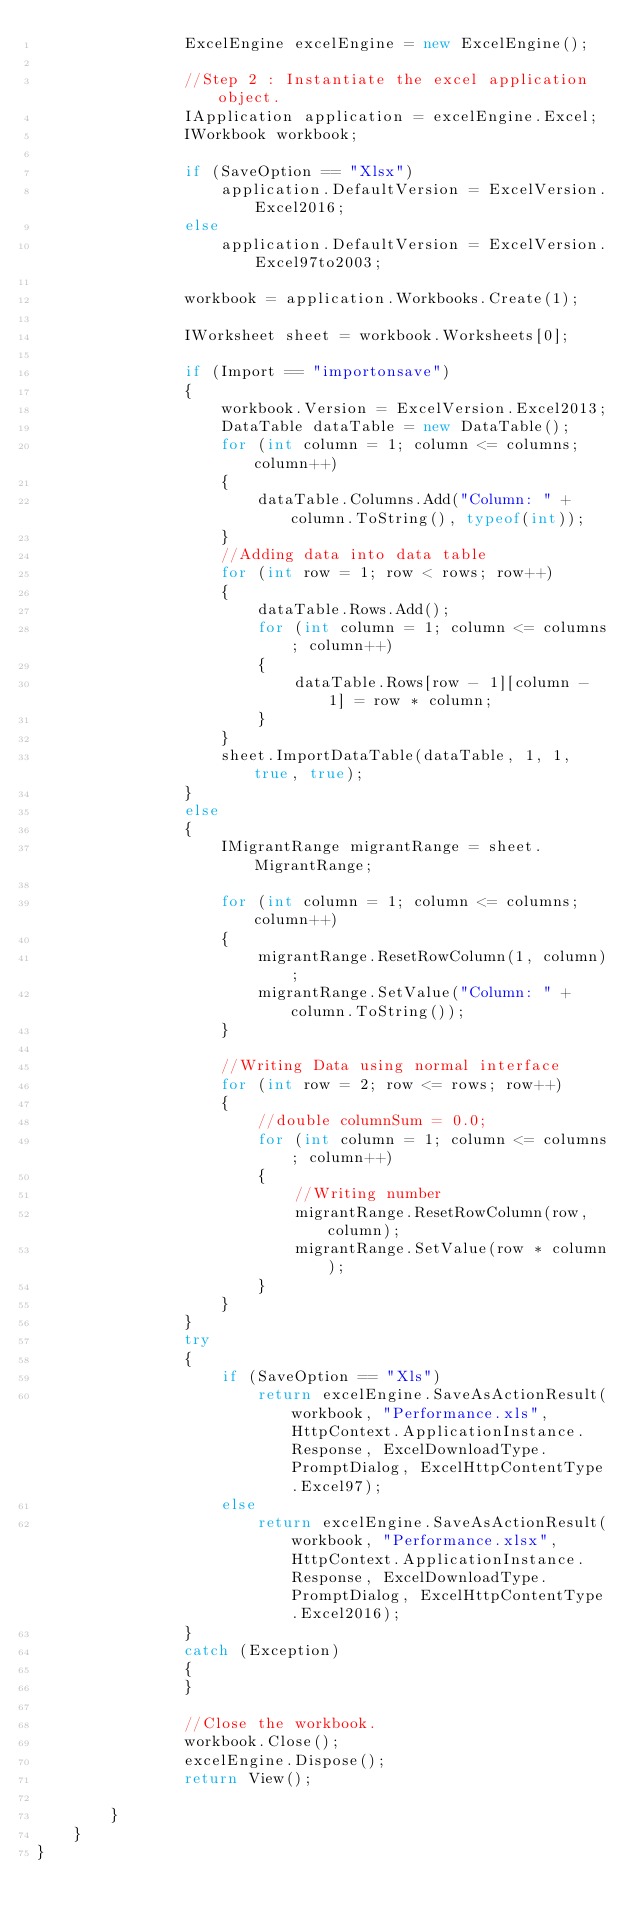Convert code to text. <code><loc_0><loc_0><loc_500><loc_500><_C#_>                ExcelEngine excelEngine = new ExcelEngine();

                //Step 2 : Instantiate the excel application object.
                IApplication application = excelEngine.Excel;
                IWorkbook workbook;

                if (SaveOption == "Xlsx")
                    application.DefaultVersion = ExcelVersion.Excel2016;
                else
                    application.DefaultVersion = ExcelVersion.Excel97to2003;
              
                workbook = application.Workbooks.Create(1);

                IWorksheet sheet = workbook.Worksheets[0];

                if (Import == "importonsave")
                {
                    workbook.Version = ExcelVersion.Excel2013;
                    DataTable dataTable = new DataTable();
                    for (int column = 1; column <= columns; column++)
                    {
                        dataTable.Columns.Add("Column: " + column.ToString(), typeof(int));
                    }
                    //Adding data into data table
                    for (int row = 1; row < rows; row++)
                    {
                        dataTable.Rows.Add();
                        for (int column = 1; column <= columns; column++)
                        {
                            dataTable.Rows[row - 1][column - 1] = row * column;
                        }
                    }
                    sheet.ImportDataTable(dataTable, 1, 1, true, true);
                }
                else
                {
                    IMigrantRange migrantRange = sheet.MigrantRange;

                    for (int column = 1; column <= columns; column++)
                    {
                        migrantRange.ResetRowColumn(1, column);
                        migrantRange.SetValue("Column: " + column.ToString());
                    }

                    //Writing Data using normal interface
                    for (int row = 2; row <= rows; row++)
                    {
                        //double columnSum = 0.0; 
                        for (int column = 1; column <= columns; column++)
                        {
                            //Writing number
                            migrantRange.ResetRowColumn(row, column);
                            migrantRange.SetValue(row * column);
                        }
                    }
                }
                try
                {
                    if (SaveOption == "Xls")
                        return excelEngine.SaveAsActionResult(workbook, "Performance.xls", HttpContext.ApplicationInstance.Response, ExcelDownloadType.PromptDialog, ExcelHttpContentType.Excel97);
                    else
                        return excelEngine.SaveAsActionResult(workbook, "Performance.xlsx", HttpContext.ApplicationInstance.Response, ExcelDownloadType.PromptDialog, ExcelHttpContentType.Excel2016);
                }
                catch (Exception)
                {
                }

                //Close the workbook.
                workbook.Close();
                excelEngine.Dispose();
                return View();
            
        }
    }
}
</code> 